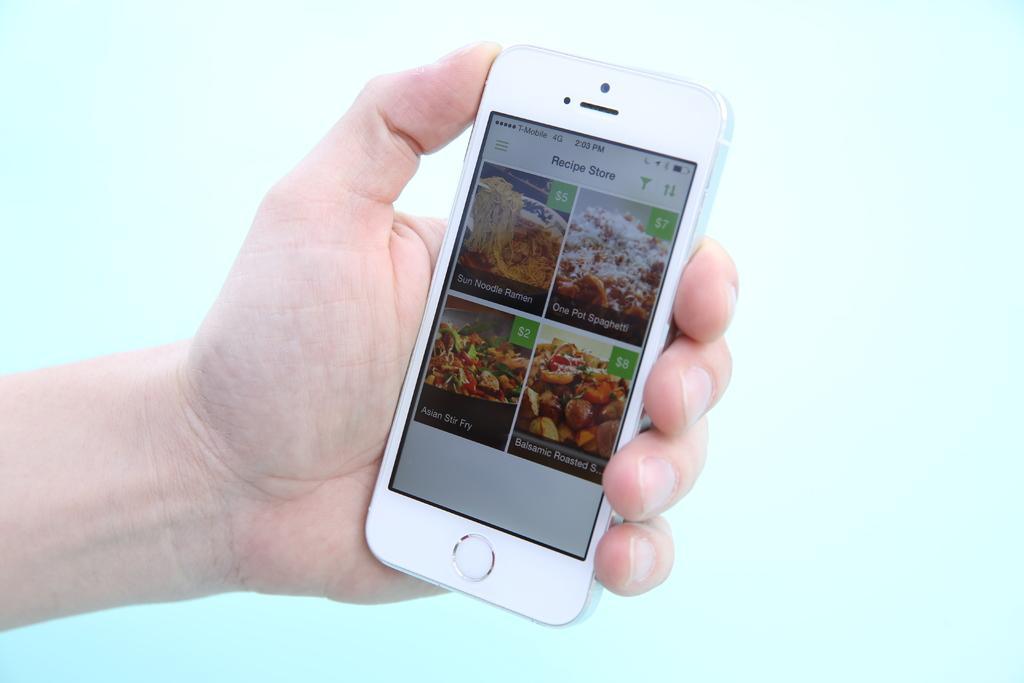In one or two sentences, can you explain what this image depicts? In this image there is one person's hand is visible, and the person is holding a mobile and on the mobile screen there is text and some pictures of food items and there is a blue background. 